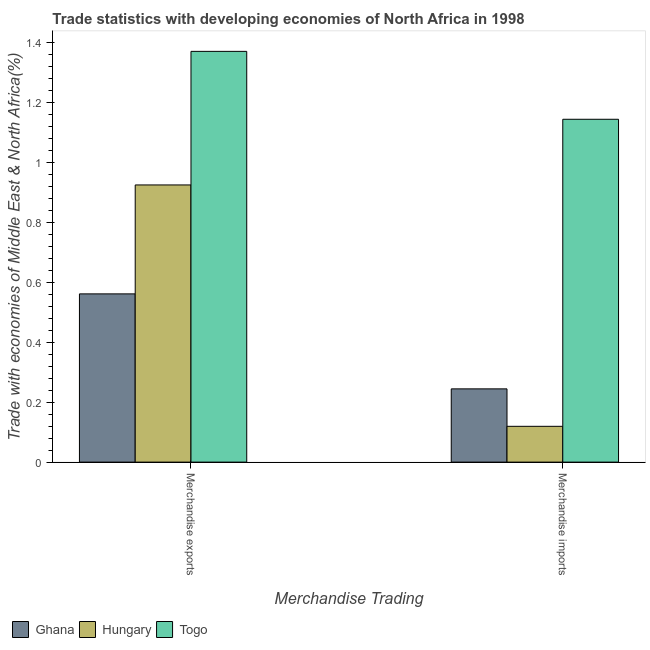How many different coloured bars are there?
Give a very brief answer. 3. Are the number of bars per tick equal to the number of legend labels?
Keep it short and to the point. Yes. How many bars are there on the 2nd tick from the right?
Give a very brief answer. 3. What is the label of the 2nd group of bars from the left?
Provide a short and direct response. Merchandise imports. What is the merchandise exports in Ghana?
Offer a very short reply. 0.56. Across all countries, what is the maximum merchandise exports?
Your answer should be compact. 1.37. Across all countries, what is the minimum merchandise exports?
Your answer should be very brief. 0.56. In which country was the merchandise exports maximum?
Offer a very short reply. Togo. In which country was the merchandise imports minimum?
Your response must be concise. Hungary. What is the total merchandise imports in the graph?
Your answer should be compact. 1.51. What is the difference between the merchandise exports in Togo and that in Hungary?
Your answer should be compact. 0.45. What is the difference between the merchandise imports in Togo and the merchandise exports in Ghana?
Your response must be concise. 0.58. What is the average merchandise imports per country?
Your answer should be compact. 0.5. What is the difference between the merchandise imports and merchandise exports in Togo?
Offer a very short reply. -0.23. In how many countries, is the merchandise exports greater than 0.68 %?
Keep it short and to the point. 2. What is the ratio of the merchandise exports in Togo to that in Hungary?
Give a very brief answer. 1.48. Is the merchandise imports in Togo less than that in Hungary?
Your answer should be very brief. No. What does the 2nd bar from the left in Merchandise exports represents?
Provide a short and direct response. Hungary. What does the 1st bar from the right in Merchandise imports represents?
Your response must be concise. Togo. Are all the bars in the graph horizontal?
Provide a short and direct response. No. How many countries are there in the graph?
Your response must be concise. 3. What is the difference between two consecutive major ticks on the Y-axis?
Your response must be concise. 0.2. Does the graph contain any zero values?
Make the answer very short. No. Does the graph contain grids?
Provide a short and direct response. No. How are the legend labels stacked?
Your answer should be very brief. Horizontal. What is the title of the graph?
Provide a short and direct response. Trade statistics with developing economies of North Africa in 1998. Does "Fiji" appear as one of the legend labels in the graph?
Keep it short and to the point. No. What is the label or title of the X-axis?
Your answer should be very brief. Merchandise Trading. What is the label or title of the Y-axis?
Offer a terse response. Trade with economies of Middle East & North Africa(%). What is the Trade with economies of Middle East & North Africa(%) of Ghana in Merchandise exports?
Ensure brevity in your answer.  0.56. What is the Trade with economies of Middle East & North Africa(%) in Hungary in Merchandise exports?
Offer a terse response. 0.92. What is the Trade with economies of Middle East & North Africa(%) in Togo in Merchandise exports?
Your answer should be very brief. 1.37. What is the Trade with economies of Middle East & North Africa(%) in Ghana in Merchandise imports?
Provide a short and direct response. 0.24. What is the Trade with economies of Middle East & North Africa(%) in Hungary in Merchandise imports?
Give a very brief answer. 0.12. What is the Trade with economies of Middle East & North Africa(%) in Togo in Merchandise imports?
Keep it short and to the point. 1.14. Across all Merchandise Trading, what is the maximum Trade with economies of Middle East & North Africa(%) of Ghana?
Make the answer very short. 0.56. Across all Merchandise Trading, what is the maximum Trade with economies of Middle East & North Africa(%) in Hungary?
Your response must be concise. 0.92. Across all Merchandise Trading, what is the maximum Trade with economies of Middle East & North Africa(%) of Togo?
Keep it short and to the point. 1.37. Across all Merchandise Trading, what is the minimum Trade with economies of Middle East & North Africa(%) of Ghana?
Your answer should be compact. 0.24. Across all Merchandise Trading, what is the minimum Trade with economies of Middle East & North Africa(%) in Hungary?
Provide a short and direct response. 0.12. Across all Merchandise Trading, what is the minimum Trade with economies of Middle East & North Africa(%) of Togo?
Your response must be concise. 1.14. What is the total Trade with economies of Middle East & North Africa(%) of Ghana in the graph?
Make the answer very short. 0.81. What is the total Trade with economies of Middle East & North Africa(%) of Hungary in the graph?
Provide a succinct answer. 1.04. What is the total Trade with economies of Middle East & North Africa(%) in Togo in the graph?
Offer a terse response. 2.51. What is the difference between the Trade with economies of Middle East & North Africa(%) in Ghana in Merchandise exports and that in Merchandise imports?
Offer a terse response. 0.32. What is the difference between the Trade with economies of Middle East & North Africa(%) of Hungary in Merchandise exports and that in Merchandise imports?
Make the answer very short. 0.8. What is the difference between the Trade with economies of Middle East & North Africa(%) of Togo in Merchandise exports and that in Merchandise imports?
Offer a terse response. 0.23. What is the difference between the Trade with economies of Middle East & North Africa(%) of Ghana in Merchandise exports and the Trade with economies of Middle East & North Africa(%) of Hungary in Merchandise imports?
Your response must be concise. 0.44. What is the difference between the Trade with economies of Middle East & North Africa(%) in Ghana in Merchandise exports and the Trade with economies of Middle East & North Africa(%) in Togo in Merchandise imports?
Your answer should be very brief. -0.58. What is the difference between the Trade with economies of Middle East & North Africa(%) of Hungary in Merchandise exports and the Trade with economies of Middle East & North Africa(%) of Togo in Merchandise imports?
Give a very brief answer. -0.22. What is the average Trade with economies of Middle East & North Africa(%) of Ghana per Merchandise Trading?
Offer a very short reply. 0.4. What is the average Trade with economies of Middle East & North Africa(%) of Hungary per Merchandise Trading?
Your answer should be compact. 0.52. What is the average Trade with economies of Middle East & North Africa(%) of Togo per Merchandise Trading?
Your answer should be very brief. 1.26. What is the difference between the Trade with economies of Middle East & North Africa(%) in Ghana and Trade with economies of Middle East & North Africa(%) in Hungary in Merchandise exports?
Your response must be concise. -0.36. What is the difference between the Trade with economies of Middle East & North Africa(%) in Ghana and Trade with economies of Middle East & North Africa(%) in Togo in Merchandise exports?
Offer a very short reply. -0.81. What is the difference between the Trade with economies of Middle East & North Africa(%) of Hungary and Trade with economies of Middle East & North Africa(%) of Togo in Merchandise exports?
Make the answer very short. -0.45. What is the difference between the Trade with economies of Middle East & North Africa(%) in Ghana and Trade with economies of Middle East & North Africa(%) in Hungary in Merchandise imports?
Keep it short and to the point. 0.12. What is the difference between the Trade with economies of Middle East & North Africa(%) of Ghana and Trade with economies of Middle East & North Africa(%) of Togo in Merchandise imports?
Your response must be concise. -0.9. What is the difference between the Trade with economies of Middle East & North Africa(%) of Hungary and Trade with economies of Middle East & North Africa(%) of Togo in Merchandise imports?
Your response must be concise. -1.02. What is the ratio of the Trade with economies of Middle East & North Africa(%) in Ghana in Merchandise exports to that in Merchandise imports?
Your response must be concise. 2.3. What is the ratio of the Trade with economies of Middle East & North Africa(%) of Hungary in Merchandise exports to that in Merchandise imports?
Offer a terse response. 7.74. What is the ratio of the Trade with economies of Middle East & North Africa(%) of Togo in Merchandise exports to that in Merchandise imports?
Your response must be concise. 1.2. What is the difference between the highest and the second highest Trade with economies of Middle East & North Africa(%) of Ghana?
Your response must be concise. 0.32. What is the difference between the highest and the second highest Trade with economies of Middle East & North Africa(%) of Hungary?
Your answer should be very brief. 0.8. What is the difference between the highest and the second highest Trade with economies of Middle East & North Africa(%) of Togo?
Ensure brevity in your answer.  0.23. What is the difference between the highest and the lowest Trade with economies of Middle East & North Africa(%) of Ghana?
Offer a very short reply. 0.32. What is the difference between the highest and the lowest Trade with economies of Middle East & North Africa(%) in Hungary?
Your answer should be very brief. 0.8. What is the difference between the highest and the lowest Trade with economies of Middle East & North Africa(%) in Togo?
Offer a terse response. 0.23. 